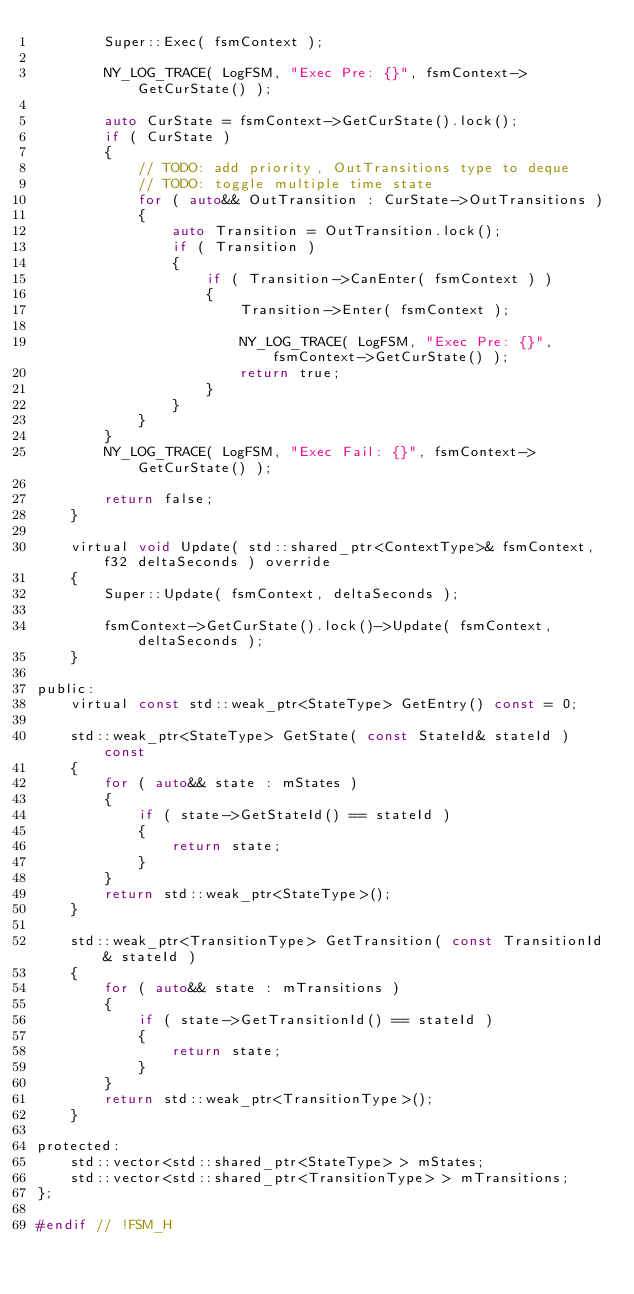Convert code to text. <code><loc_0><loc_0><loc_500><loc_500><_C_>        Super::Exec( fsmContext );

        NY_LOG_TRACE( LogFSM, "Exec Pre: {}", fsmContext->GetCurState() );

        auto CurState = fsmContext->GetCurState().lock();
        if ( CurState )
        {
            // TODO: add priority, OutTransitions type to deque
            // TODO: toggle multiple time state
            for ( auto&& OutTransition : CurState->OutTransitions )
            {
                auto Transition = OutTransition.lock();
                if ( Transition )
                {
                    if ( Transition->CanEnter( fsmContext ) )
                    {
                        Transition->Enter( fsmContext );

                        NY_LOG_TRACE( LogFSM, "Exec Pre: {}", fsmContext->GetCurState() );
                        return true;
                    }
                }
            }
        }
        NY_LOG_TRACE( LogFSM, "Exec Fail: {}", fsmContext->GetCurState() );

        return false;
    }

    virtual void Update( std::shared_ptr<ContextType>& fsmContext, f32 deltaSeconds ) override
    {
        Super::Update( fsmContext, deltaSeconds );

        fsmContext->GetCurState().lock()->Update( fsmContext, deltaSeconds );
    }

public:
    virtual const std::weak_ptr<StateType> GetEntry() const = 0;

    std::weak_ptr<StateType> GetState( const StateId& stateId ) const
    {
        for ( auto&& state : mStates )
        {
            if ( state->GetStateId() == stateId )
            {
                return state;
            }
        }
        return std::weak_ptr<StateType>();
    }

    std::weak_ptr<TransitionType> GetTransition( const TransitionId& stateId )
    {
        for ( auto&& state : mTransitions )
        {
            if ( state->GetTransitionId() == stateId )
            {
                return state;
            }
        }
        return std::weak_ptr<TransitionType>();
    }

protected:
    std::vector<std::shared_ptr<StateType> > mStates;
    std::vector<std::shared_ptr<TransitionType> > mTransitions;
};

#endif // !FSM_H</code> 